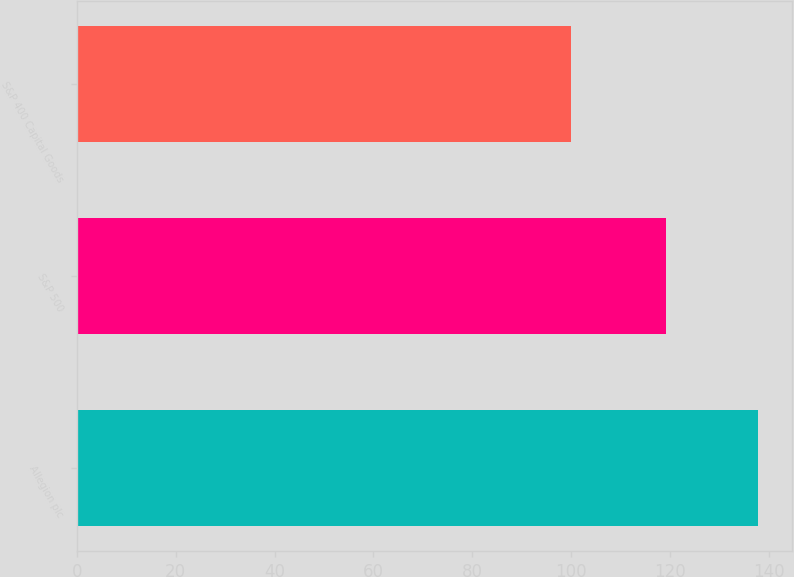Convert chart to OTSL. <chart><loc_0><loc_0><loc_500><loc_500><bar_chart><fcel>Allegion plc<fcel>S&P 500<fcel>S&P 400 Capital Goods<nl><fcel>137.71<fcel>119.22<fcel>99.9<nl></chart> 